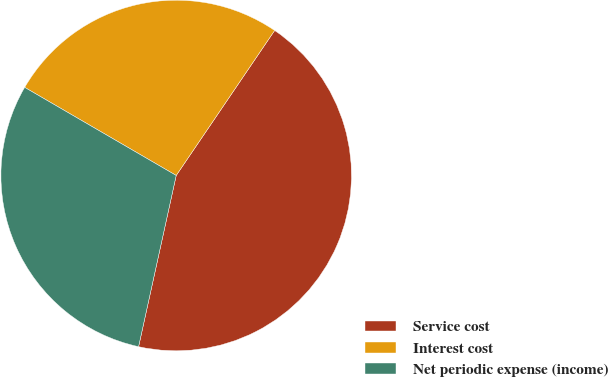Convert chart to OTSL. <chart><loc_0><loc_0><loc_500><loc_500><pie_chart><fcel>Service cost<fcel>Interest cost<fcel>Net periodic expense (income)<nl><fcel>43.95%<fcel>26.11%<fcel>29.94%<nl></chart> 